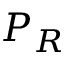Convert formula to latex. <formula><loc_0><loc_0><loc_500><loc_500>P _ { R }</formula> 